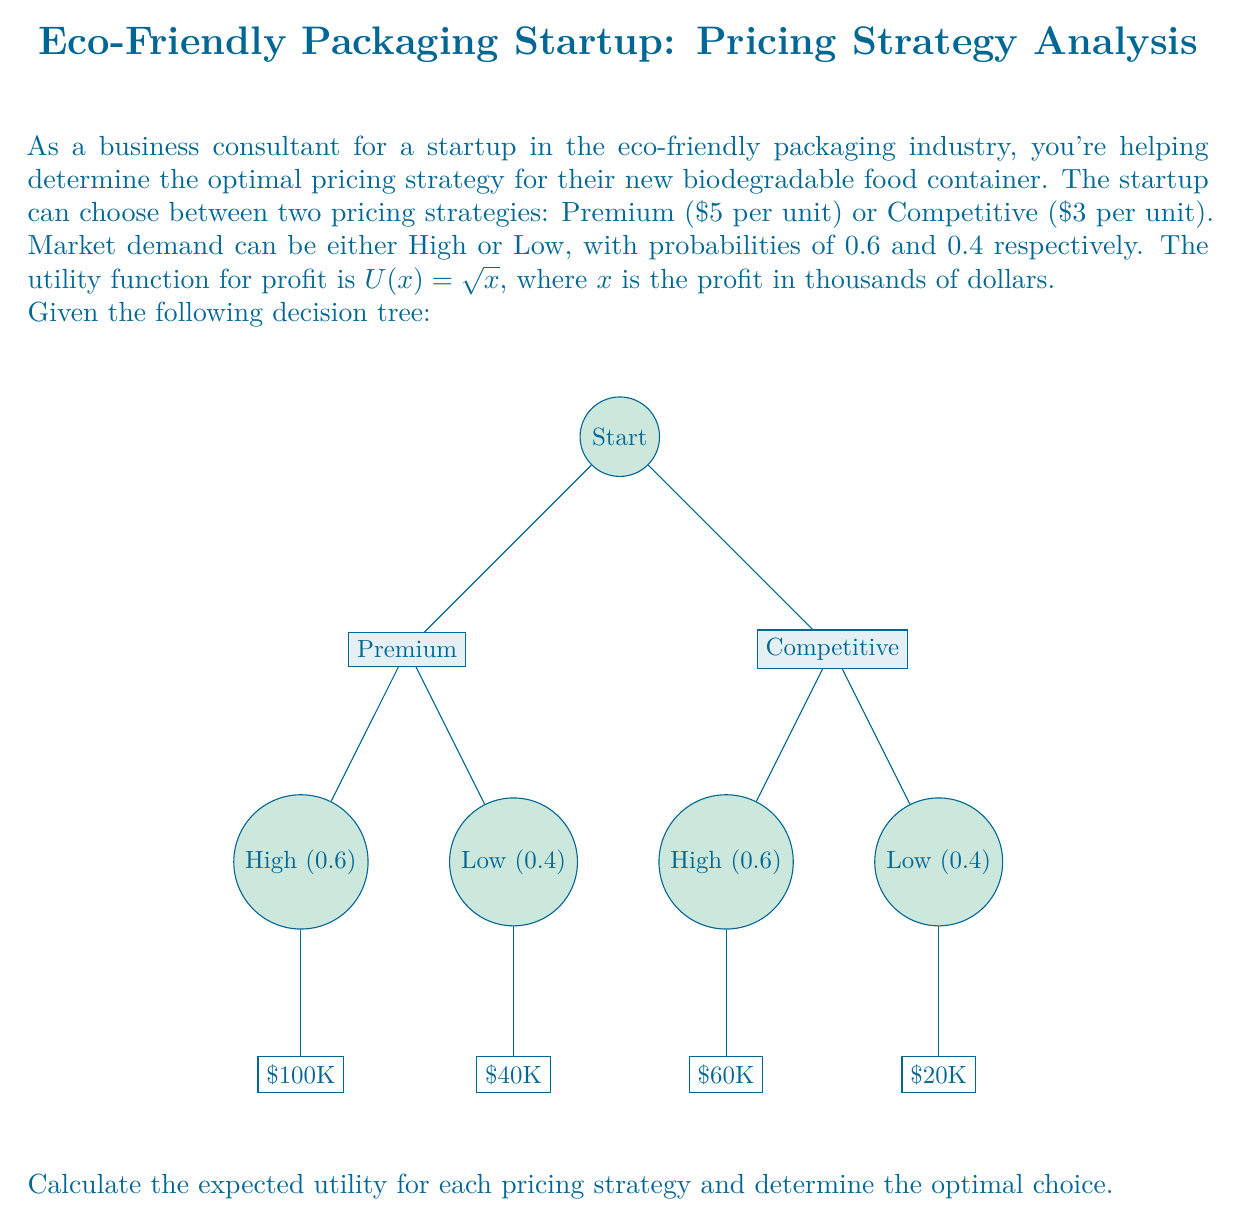Teach me how to tackle this problem. Let's solve this problem step-by-step:

1) First, we need to calculate the expected utility for each pricing strategy.

2) For the Premium strategy:
   - High demand (0.6 probability): $U(100) = \sqrt{100} = 10$
   - Low demand (0.4 probability): $U(40) = \sqrt{40} = 6.32$
   
   Expected Utility (Premium) = $0.6 * 10 + 0.4 * 6.32 = 6 + 2.53 = 8.53$

3) For the Competitive strategy:
   - High demand (0.6 probability): $U(60) = \sqrt{60} = 7.75$
   - Low demand (0.4 probability): $U(20) = \sqrt{20} = 4.47$
   
   Expected Utility (Competitive) = $0.6 * 7.75 + 0.4 * 4.47 = 4.65 + 1.79 = 6.44$

4) Compare the expected utilities:
   Premium strategy: 8.53
   Competitive strategy: 6.44

5) The optimal choice is the strategy with the higher expected utility.
Answer: Premium pricing strategy (Expected Utility = 8.53) 